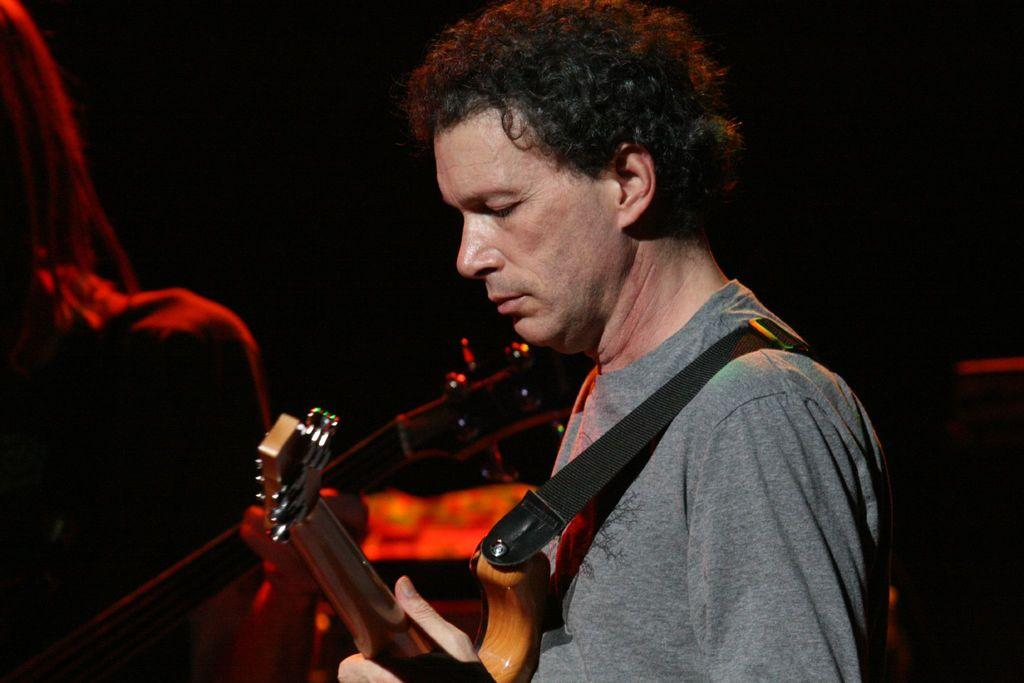Who is the main subject in the image? There is a person in the center of the image. What is the person wearing? The person is wearing a guitar. What is the person holding in the image? The person is holding a guitar. Can you describe the lady in the image? There is a lady in the image, but no specific details about her are provided. What type of musical instrument can be seen in the image? There is a musical instrument in the image, which is a guitar. What is the color of the background in the image? The background of the image is dark. Can you tell me how many chess pieces are on the table in the image? There is no table or chess pieces present in the image. What type of boot is the person wearing in the image? The person is wearing a guitar, not a boot, in the image. 